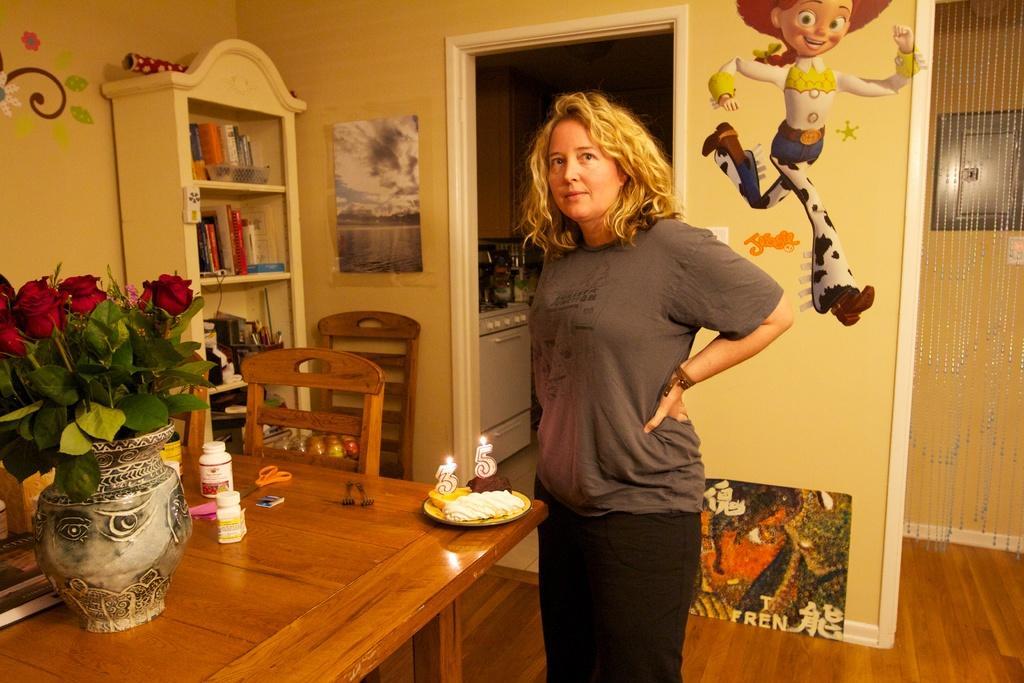Please provide a concise description of this image. The women wearing a grey shirt is standing and there is a cake in front of her which has written thirty five on it and there is also a flower vase having roses in it and there is also a bookshelf on the left side and the wall is yellow in color with cartoons drawn on it. 